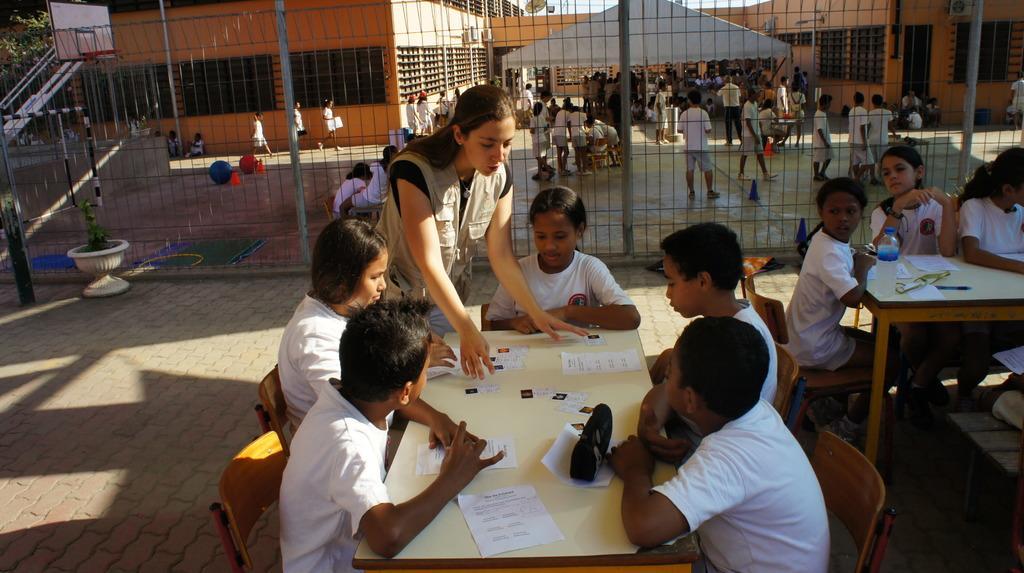How would you summarize this image in a sentence or two? In this image we can see children standing on the floor and some are sitting on the chairs and tables are in front of them. On the tables we can see papers and pouches. In the background we can see play area, houseplants, buildings, street lights, air conditioners, poles and sky. 